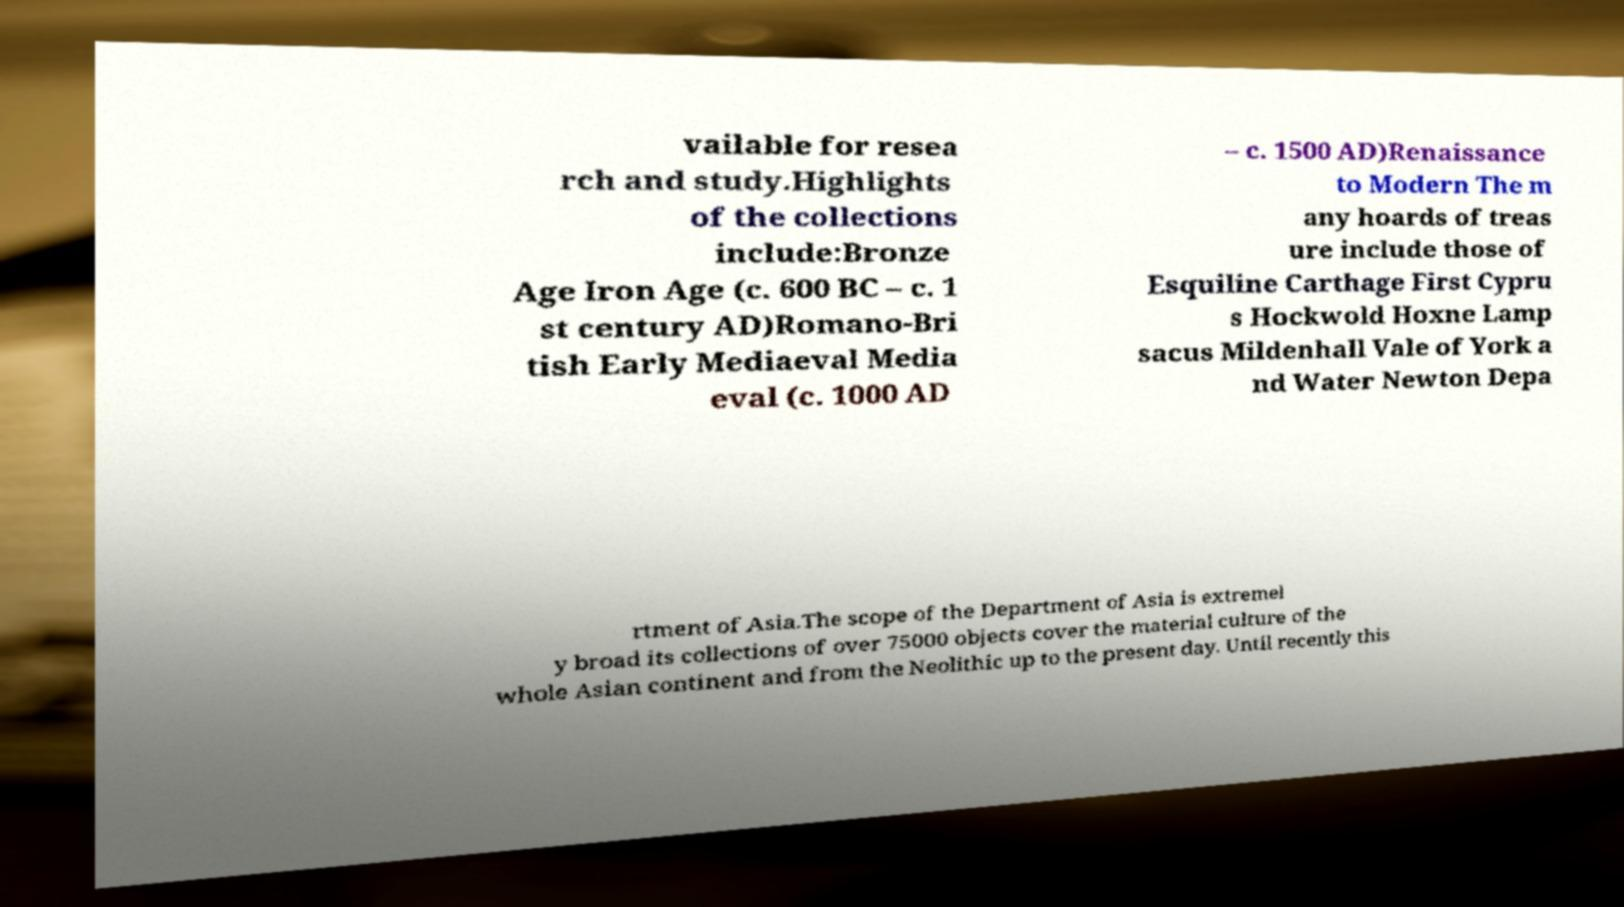For documentation purposes, I need the text within this image transcribed. Could you provide that? vailable for resea rch and study.Highlights of the collections include:Bronze Age Iron Age (c. 600 BC – c. 1 st century AD)Romano-Bri tish Early Mediaeval Media eval (c. 1000 AD – c. 1500 AD)Renaissance to Modern The m any hoards of treas ure include those of Esquiline Carthage First Cypru s Hockwold Hoxne Lamp sacus Mildenhall Vale of York a nd Water Newton Depa rtment of Asia.The scope of the Department of Asia is extremel y broad its collections of over 75000 objects cover the material culture of the whole Asian continent and from the Neolithic up to the present day. Until recently this 